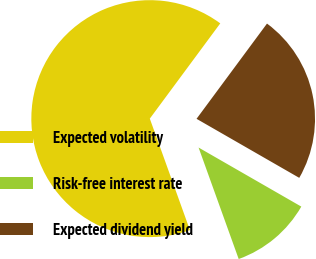Convert chart. <chart><loc_0><loc_0><loc_500><loc_500><pie_chart><fcel>Expected volatility<fcel>Risk-free interest rate<fcel>Expected dividend yield<nl><fcel>65.64%<fcel>11.2%<fcel>23.17%<nl></chart> 